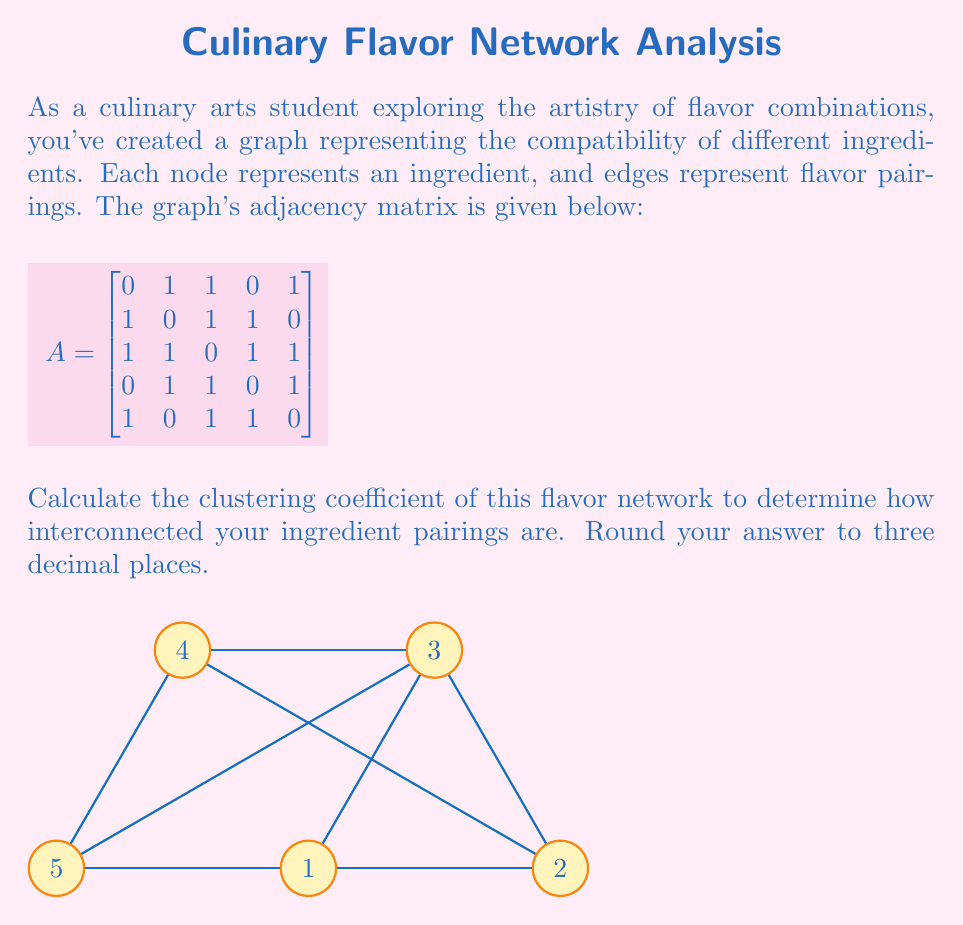Could you help me with this problem? To calculate the clustering coefficient of the flavor network, we'll follow these steps:

1) The clustering coefficient $C$ is given by:

   $$C = \frac{3 \times \text{number of triangles}}{\text{number of connected triples}}$$

2) First, let's count the number of triangles in the graph. A triangle exists when three nodes are all connected to each other. We can find this by checking for 3-cycles in the graph:

   - 1-2-3-1
   - 1-3-5-1
   - 2-3-4-2
   - 3-4-5-3

   There are 4 triangles in total.

3) Next, we need to count the number of connected triples. A connected triple is a set of three nodes where at least one node is connected to both others. We can count this by looking at each node and counting the number of pairs of its neighbors:

   - Node 1: $\binom{3}{2} = 3$ triples
   - Node 2: $\binom{3}{2} = 3$ triples
   - Node 3: $\binom{4}{2} = 6$ triples
   - Node 4: $\binom{3}{2} = 3$ triples
   - Node 5: $\binom{3}{2} = 3$ triples

   Total connected triples: 18

4) Now we can apply the formula:

   $$C = \frac{3 \times 4}{18} = \frac{12}{18} = \frac{2}{3} \approx 0.667$$

5) Rounding to three decimal places gives us 0.667.

This high clustering coefficient indicates that your flavor network is highly interconnected, suggesting that many of your ingredients pair well with multiple other ingredients in your culinary creations.
Answer: 0.667 